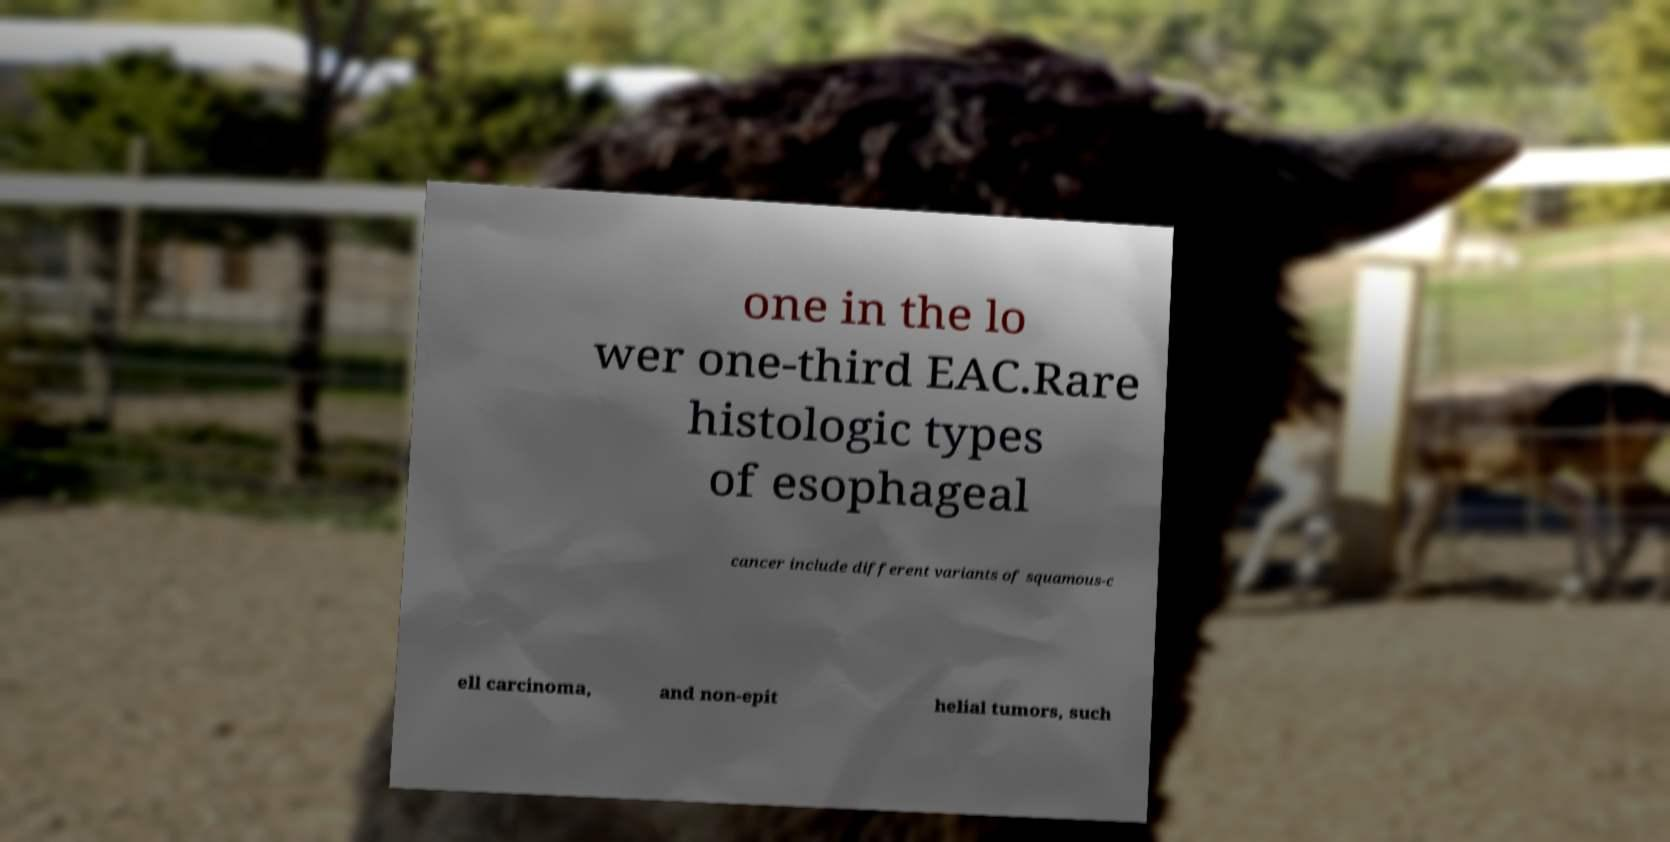Could you assist in decoding the text presented in this image and type it out clearly? one in the lo wer one-third EAC.Rare histologic types of esophageal cancer include different variants of squamous-c ell carcinoma, and non-epit helial tumors, such 